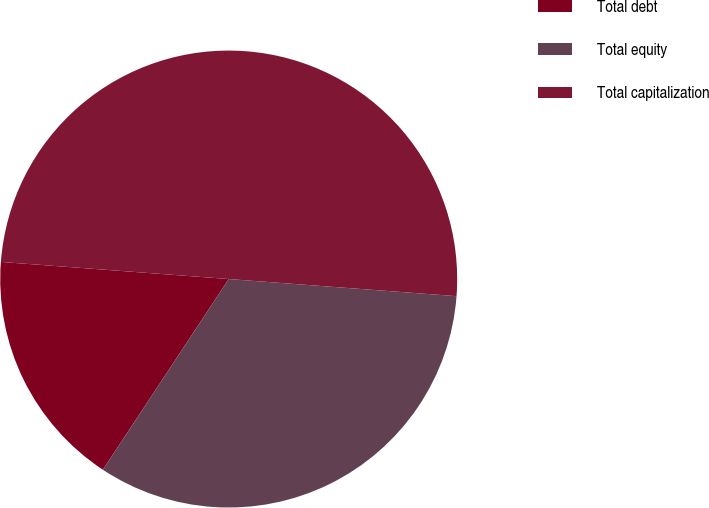Convert chart. <chart><loc_0><loc_0><loc_500><loc_500><pie_chart><fcel>Total debt<fcel>Total equity<fcel>Total capitalization<nl><fcel>16.91%<fcel>33.09%<fcel>50.0%<nl></chart> 